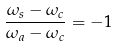Convert formula to latex. <formula><loc_0><loc_0><loc_500><loc_500>\frac { \omega _ { s } - \omega _ { c } } { \omega _ { a } - \omega _ { c } } = - 1</formula> 